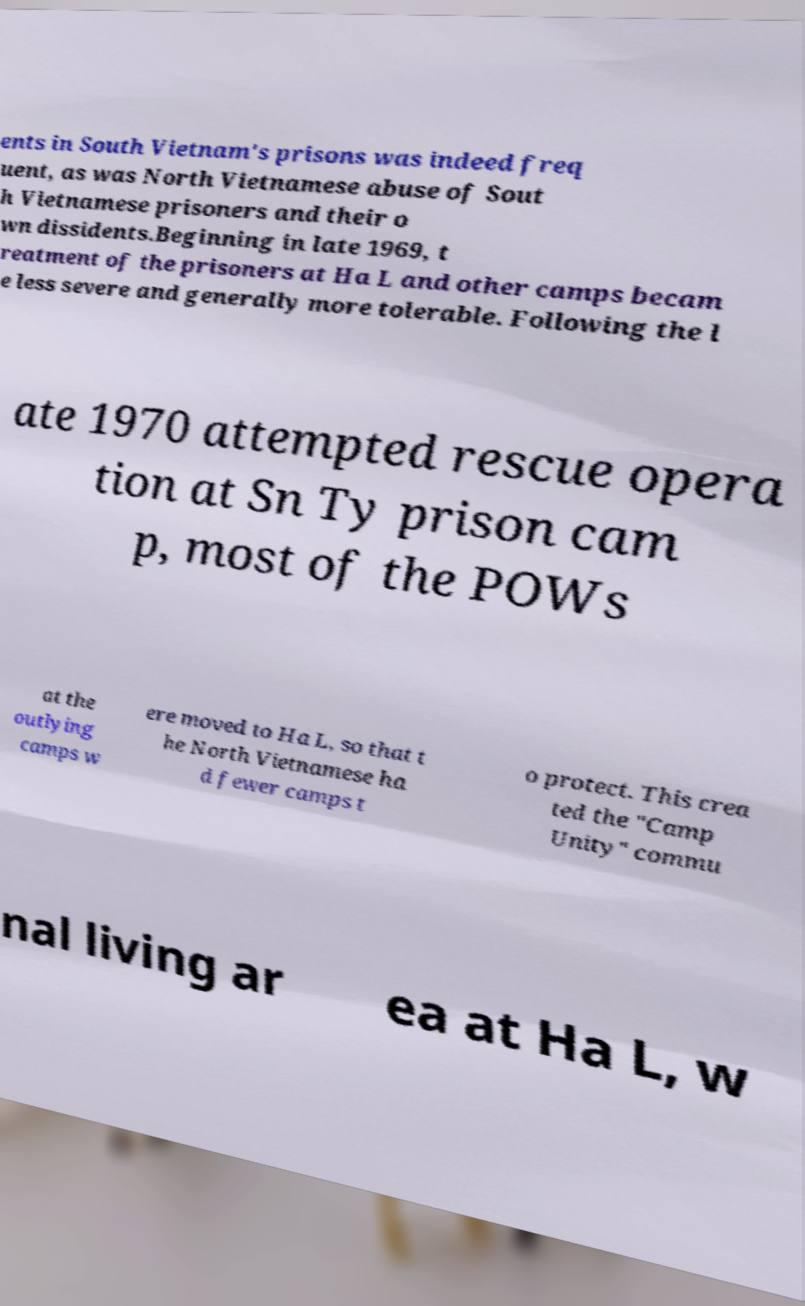There's text embedded in this image that I need extracted. Can you transcribe it verbatim? ents in South Vietnam's prisons was indeed freq uent, as was North Vietnamese abuse of Sout h Vietnamese prisoners and their o wn dissidents.Beginning in late 1969, t reatment of the prisoners at Ha L and other camps becam e less severe and generally more tolerable. Following the l ate 1970 attempted rescue opera tion at Sn Ty prison cam p, most of the POWs at the outlying camps w ere moved to Ha L, so that t he North Vietnamese ha d fewer camps t o protect. This crea ted the "Camp Unity" commu nal living ar ea at Ha L, w 